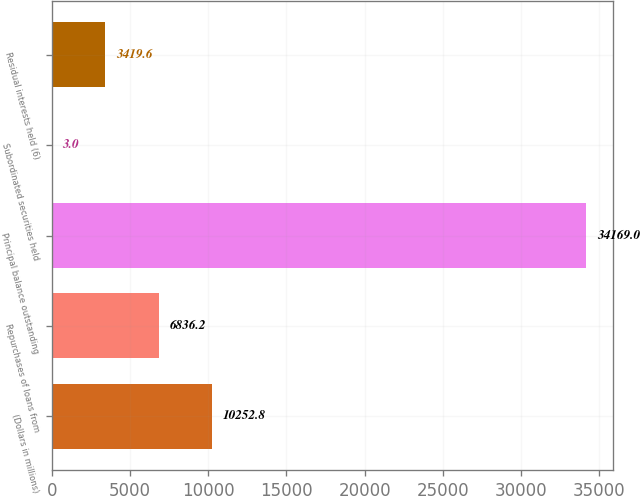<chart> <loc_0><loc_0><loc_500><loc_500><bar_chart><fcel>(Dollars in millions)<fcel>Repurchases of loans from<fcel>Principal balance outstanding<fcel>Subordinated securities held<fcel>Residual interests held (6)<nl><fcel>10252.8<fcel>6836.2<fcel>34169<fcel>3<fcel>3419.6<nl></chart> 